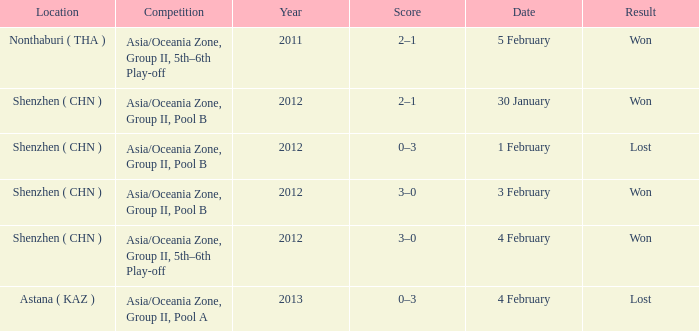What was the location for a year later than 2012? Astana ( KAZ ). 